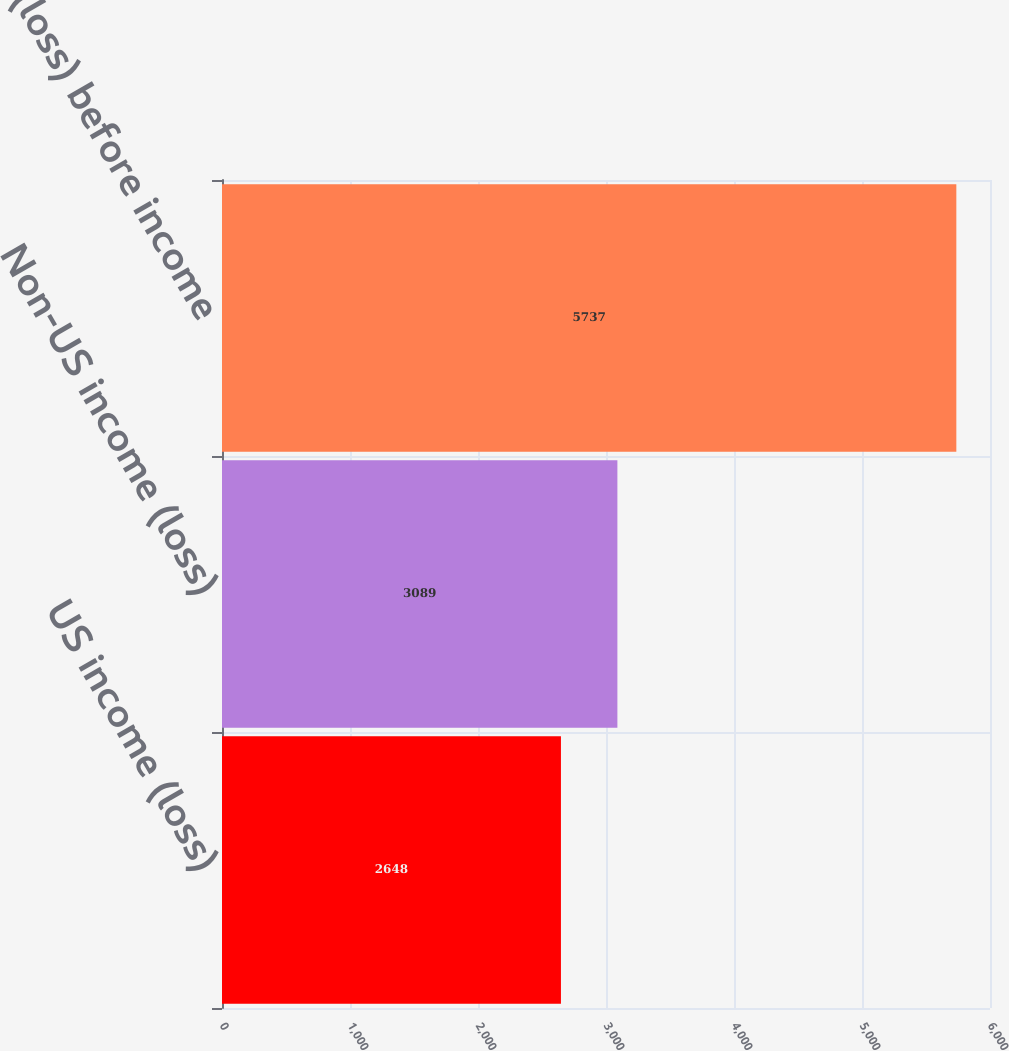Convert chart to OTSL. <chart><loc_0><loc_0><loc_500><loc_500><bar_chart><fcel>US income (loss)<fcel>Non-US income (loss)<fcel>Income (loss) before income<nl><fcel>2648<fcel>3089<fcel>5737<nl></chart> 